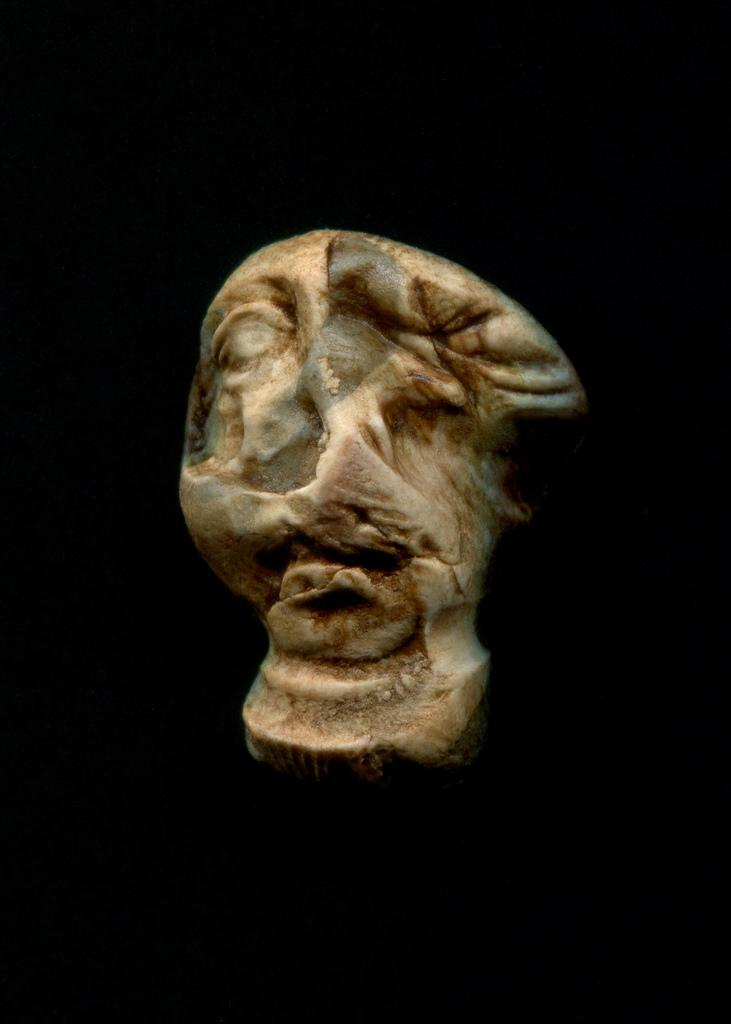What is the main subject of the image? There is a sculpture in the image. What can be observed about the background of the image? The background of the image is dark. What type of stem is depicted in the sculpture? There is no stem present in the image, as it features a sculpture. What story does the sculpture tell in the image? The image does not provide any information about a story associated with the sculpture. 